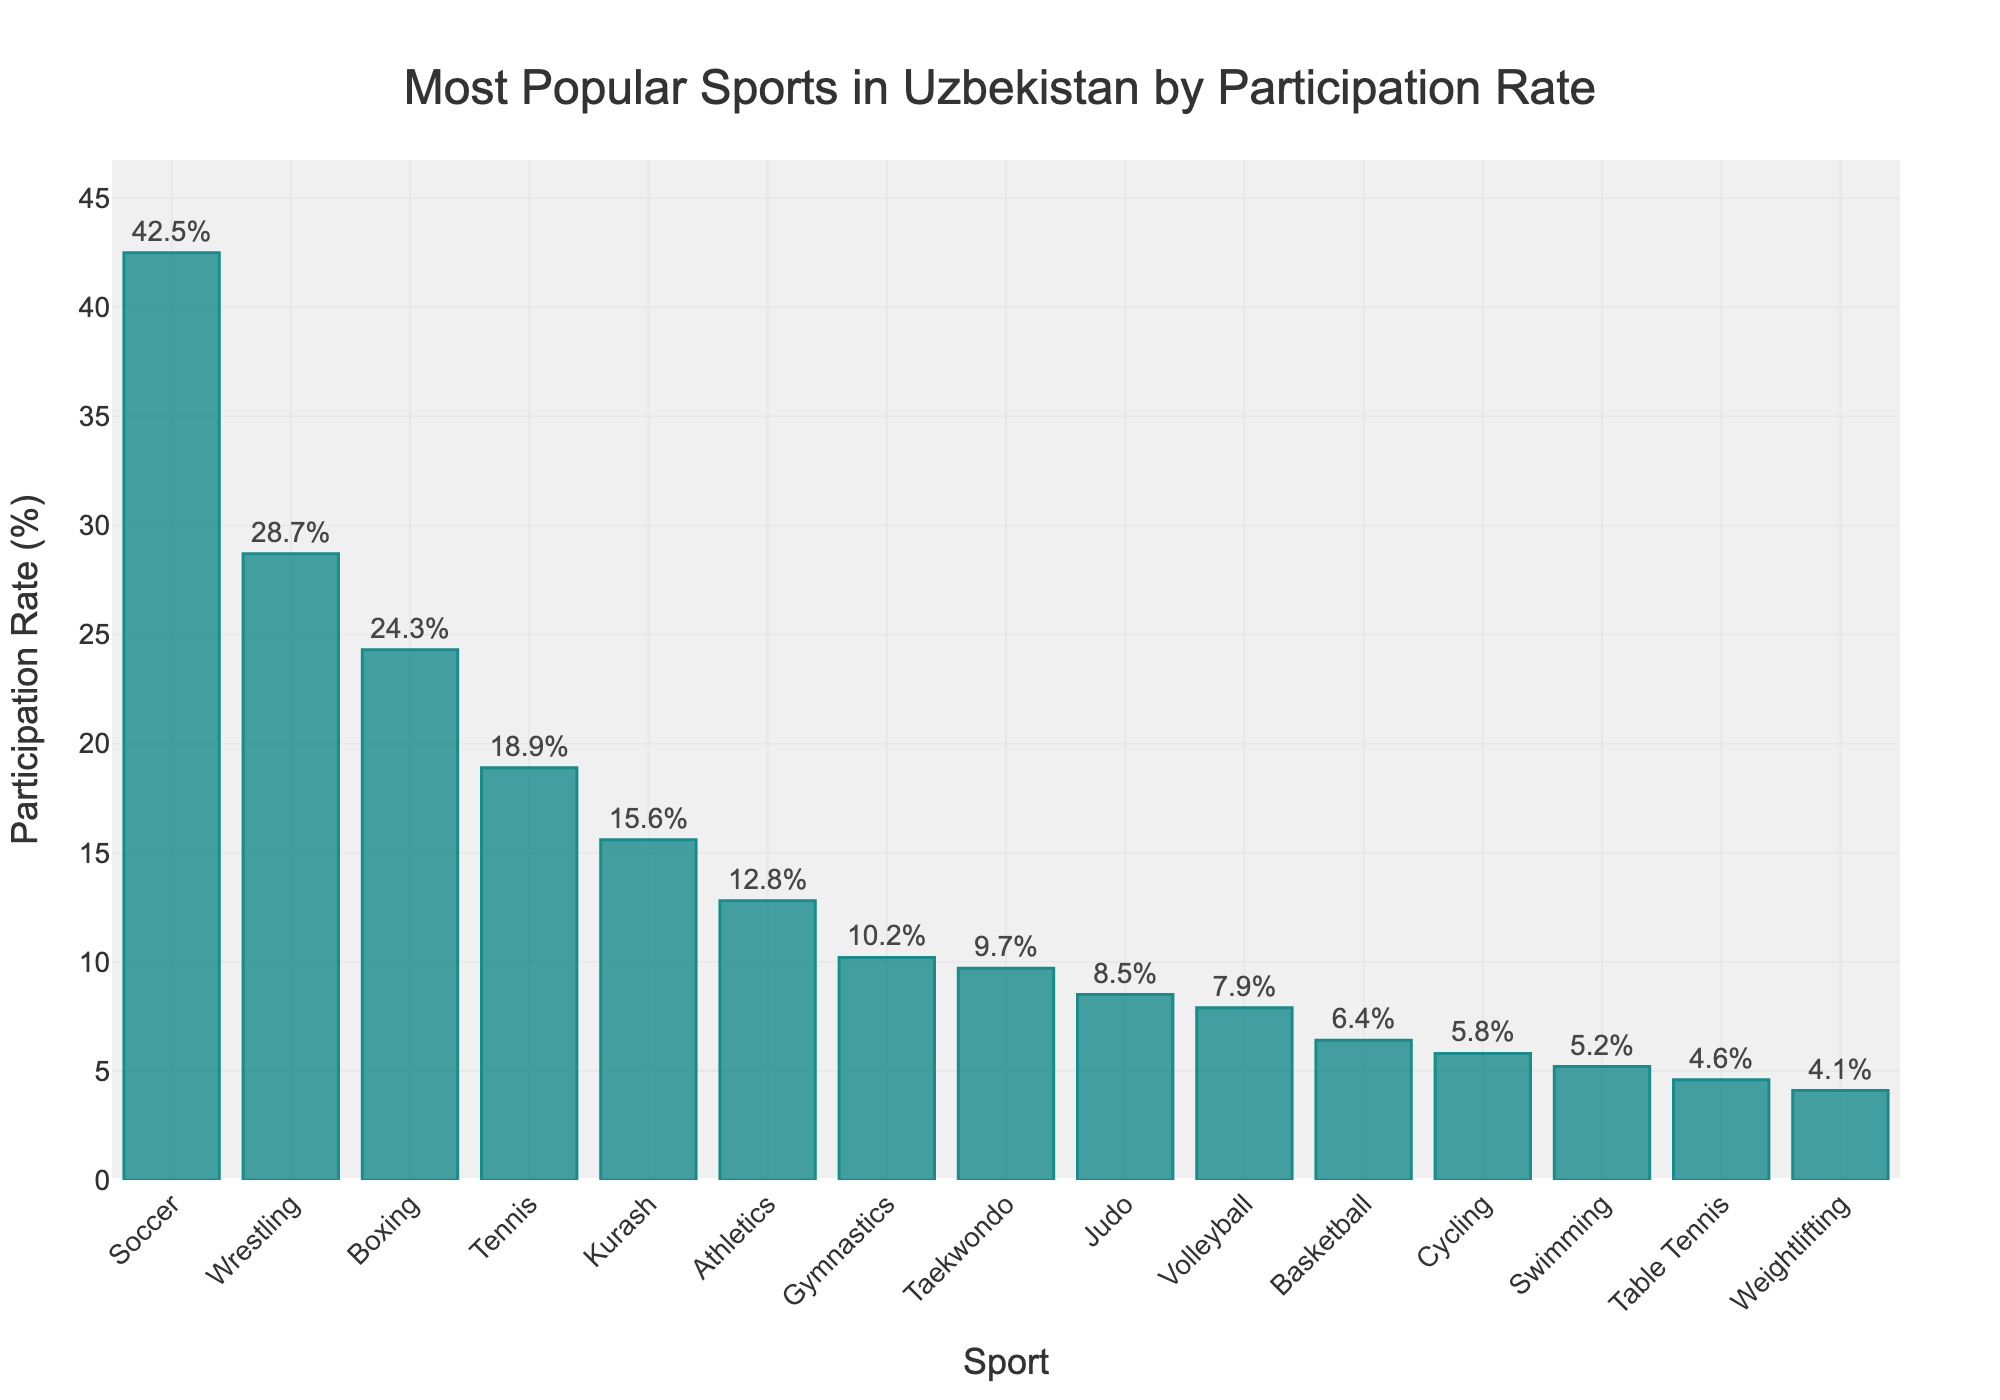What sport has the highest participation rate? The highest bar in the chart belongs to Soccer with a participation rate of 42.5%.
Answer: Soccer What is the participation rate difference between Wrestling and Cycling? The participation rate for Wrestling is 28.7%, and for Cycling, it is 5.8%. The difference is 28.7% - 5.8% = 22.9%.
Answer: 22.9% Which sport has a higher participation rate, Boxing or Tennis? The participation rate for Boxing is 24.3%, and for Tennis, it is 18.9%. Since 24.3% > 18.9%, Boxing has a higher participation rate.
Answer: Boxing What is the combined participation rate of Gymnastics, Taekwondo, and Judo? The participation rates are Gymnastics: 10.2%, Taekwondo: 9.7%, Judo: 8.5%. Combined rate = 10.2% + 9.7% + 8.5% = 28.4%.
Answer: 28.4% Which sport has the lowest participation rate, Table Tennis or Weightlifting? The participation rate for Table Tennis is 4.6%, and for Weightlifting, it is 4.1%. Since 4.1% < 4.6%, Weightlifting has the lower participation rate.
Answer: Weightlifting What is the average participation rate of the top 3 sports? The top 3 sports by participation rate are Soccer (42.5%), Wrestling (28.7%), and Boxing (24.3%). Average rate = (42.5% + 28.7% + 24.3%) / 3 = 95.5% / 3 = 31.83%.
Answer: 31.83% Is the participation rate of Swimming greater than half of the participation rate of Wrestling? The participation rate of Swimming is 5.2%, and that of Wrestling is 28.7%. Half of the Wrestling rate is 28.7% / 2 = 14.35%. Since 5.2% < 14.35%, Swimming's rate is not greater than half of Wrestling's.
Answer: No Which three sports have the closest participation rates to each other? The three sports with closest participation rates are Cycling (5.8%), Swimming (5.2%), and Table Tennis (4.6%) as their rates are very close to each other.
Answer: Cycling, Swimming, Table Tennis How many sports have a participation rate of less than 10%? By examining the chart, we see that Taekwondo, Judo, Volleyball, Basketball, Cycling, Swimming, Table Tennis, and Weightlifting each have a participation rate of less than 10%. Counting these, there are 8 sports.
Answer: 8 